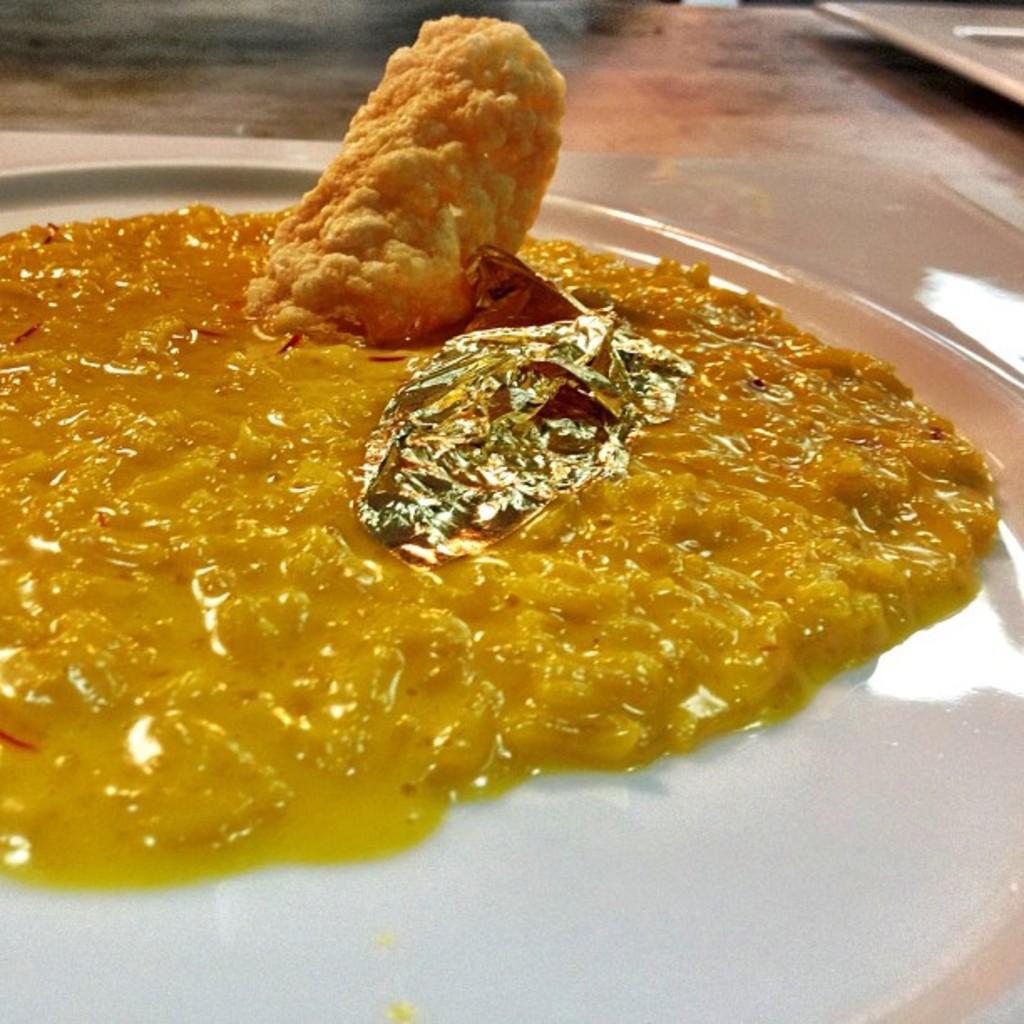Describe this image in one or two sentences. In this picture we can observe some food places in the white color plate. The food is in yellow color. The plate is placed on the table. 